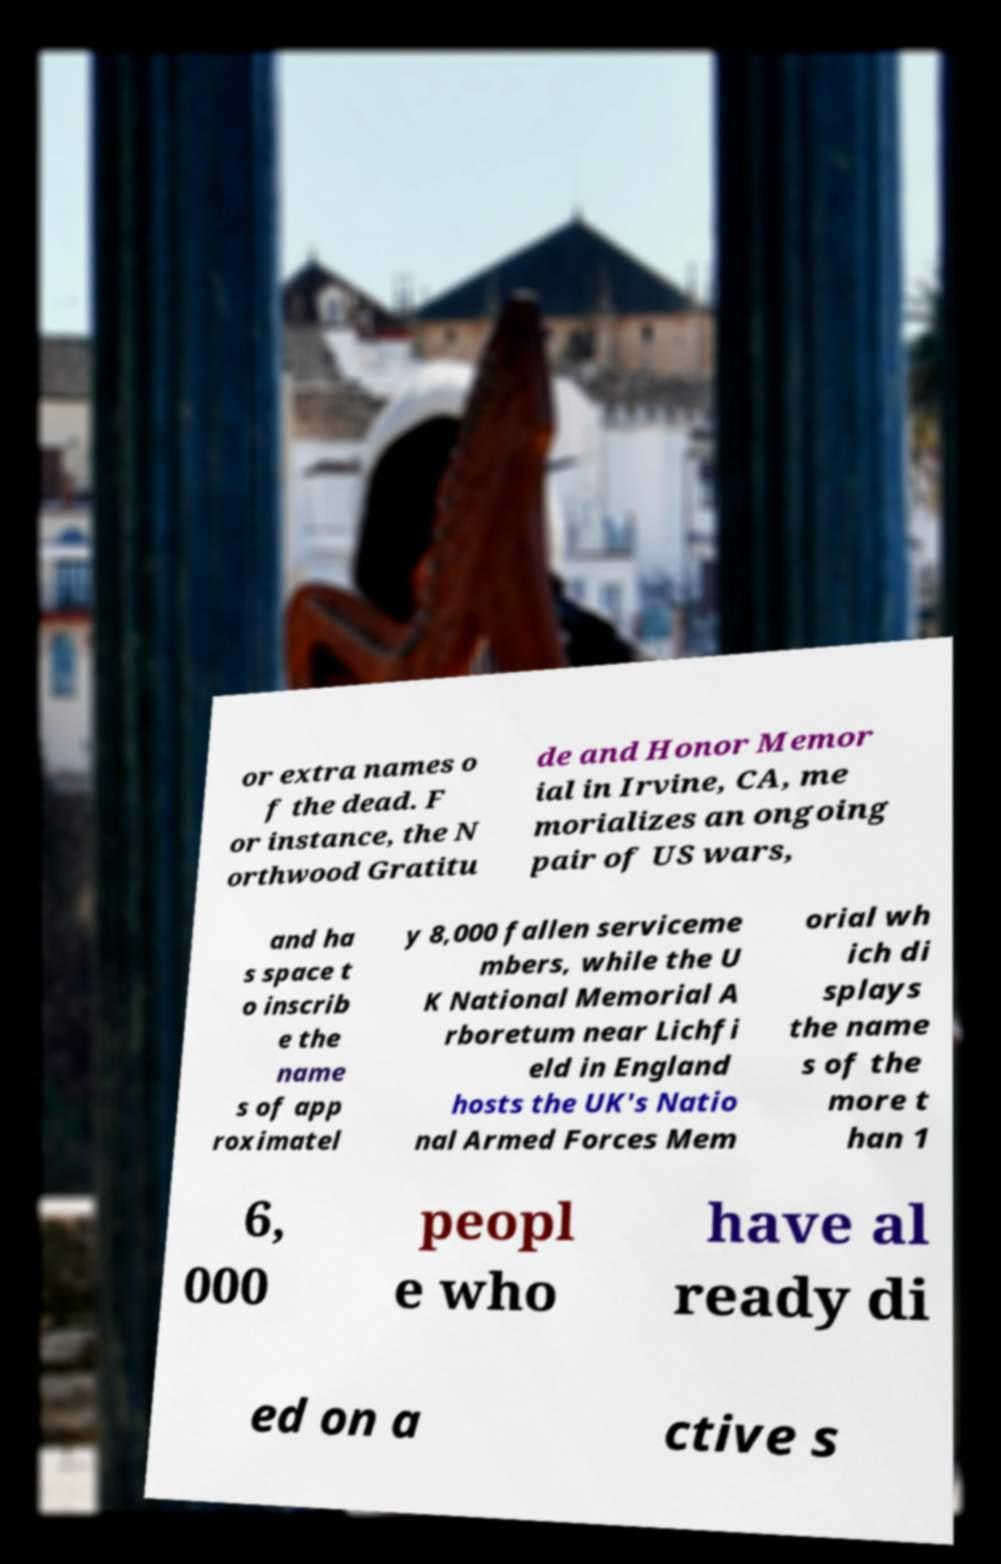Could you extract and type out the text from this image? or extra names o f the dead. F or instance, the N orthwood Gratitu de and Honor Memor ial in Irvine, CA, me morializes an ongoing pair of US wars, and ha s space t o inscrib e the name s of app roximatel y 8,000 fallen serviceme mbers, while the U K National Memorial A rboretum near Lichfi eld in England hosts the UK's Natio nal Armed Forces Mem orial wh ich di splays the name s of the more t han 1 6, 000 peopl e who have al ready di ed on a ctive s 